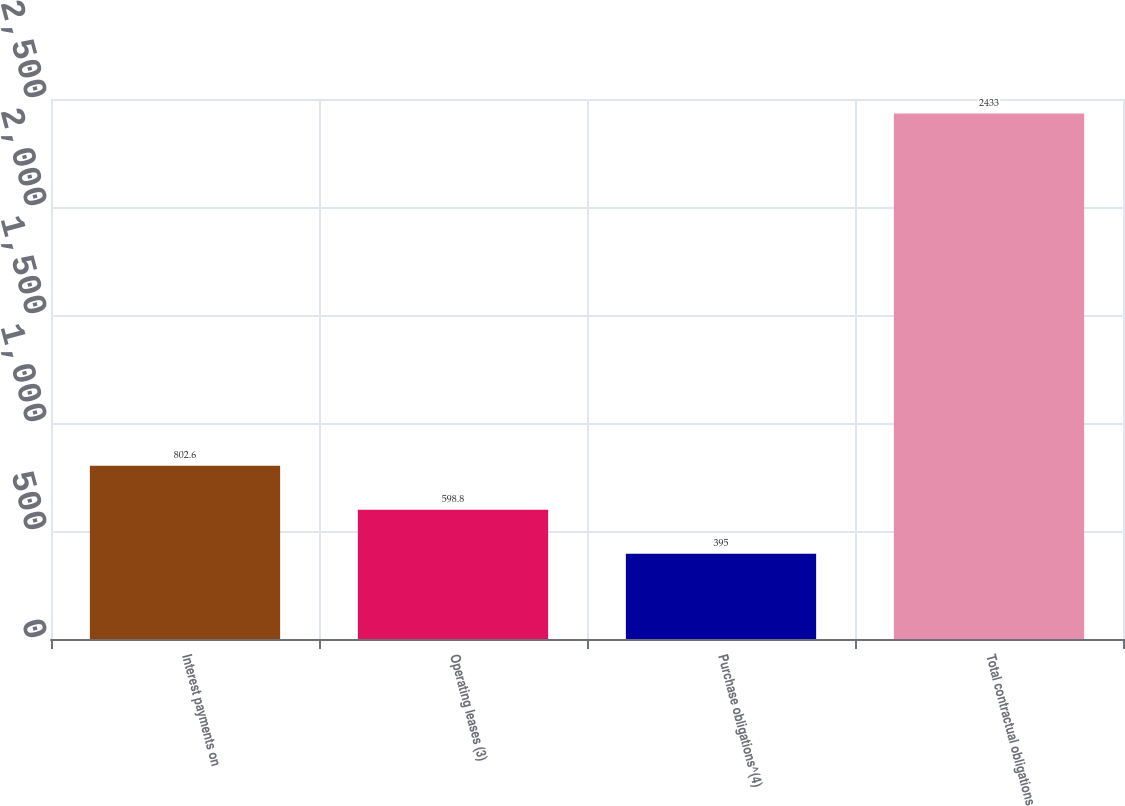Convert chart to OTSL. <chart><loc_0><loc_0><loc_500><loc_500><bar_chart><fcel>Interest payments on<fcel>Operating leases (3)<fcel>Purchase obligations^(4)<fcel>Total contractual obligations<nl><fcel>802.6<fcel>598.8<fcel>395<fcel>2433<nl></chart> 